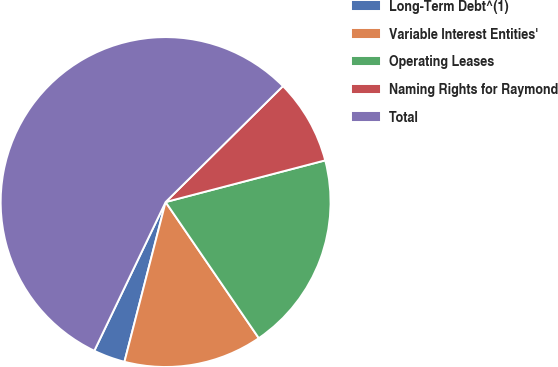Convert chart to OTSL. <chart><loc_0><loc_0><loc_500><loc_500><pie_chart><fcel>Long-Term Debt^(1)<fcel>Variable Interest Entities'<fcel>Operating Leases<fcel>Naming Rights for Raymond<fcel>Total<nl><fcel>3.1%<fcel>13.57%<fcel>19.51%<fcel>8.34%<fcel>55.48%<nl></chart> 